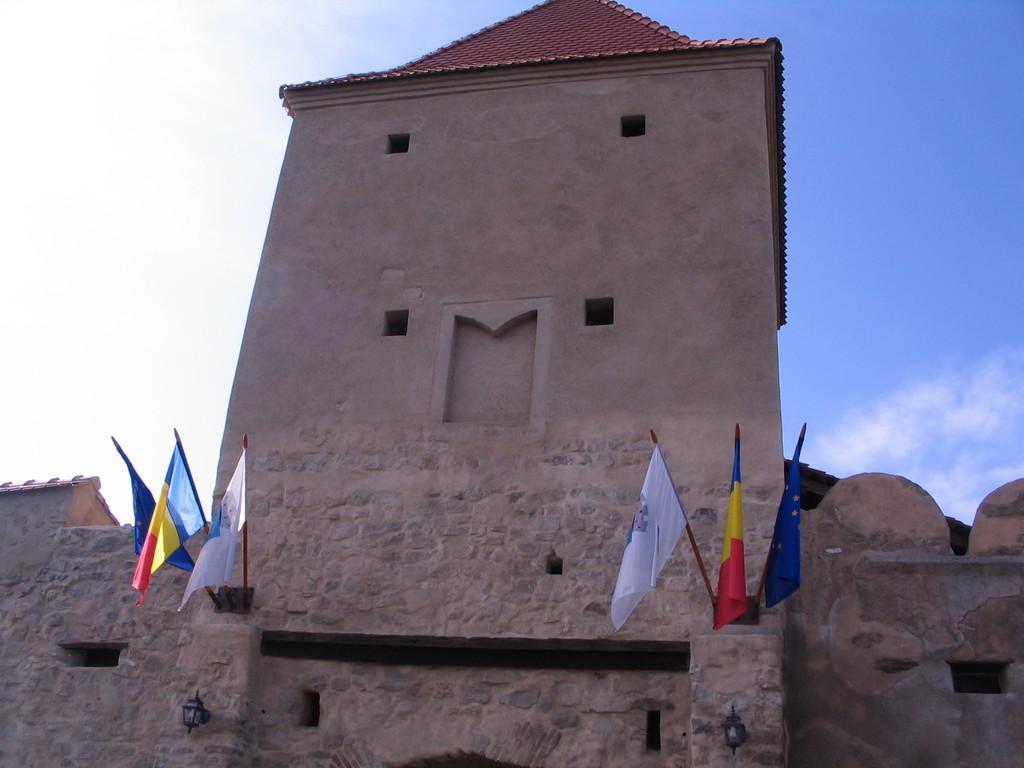How would you summarize this image in a sentence or two? In this image I can see a building in brown color, in front I can see few flags in white, red, yellow and blue color. Background the sky is in white and blue color. 